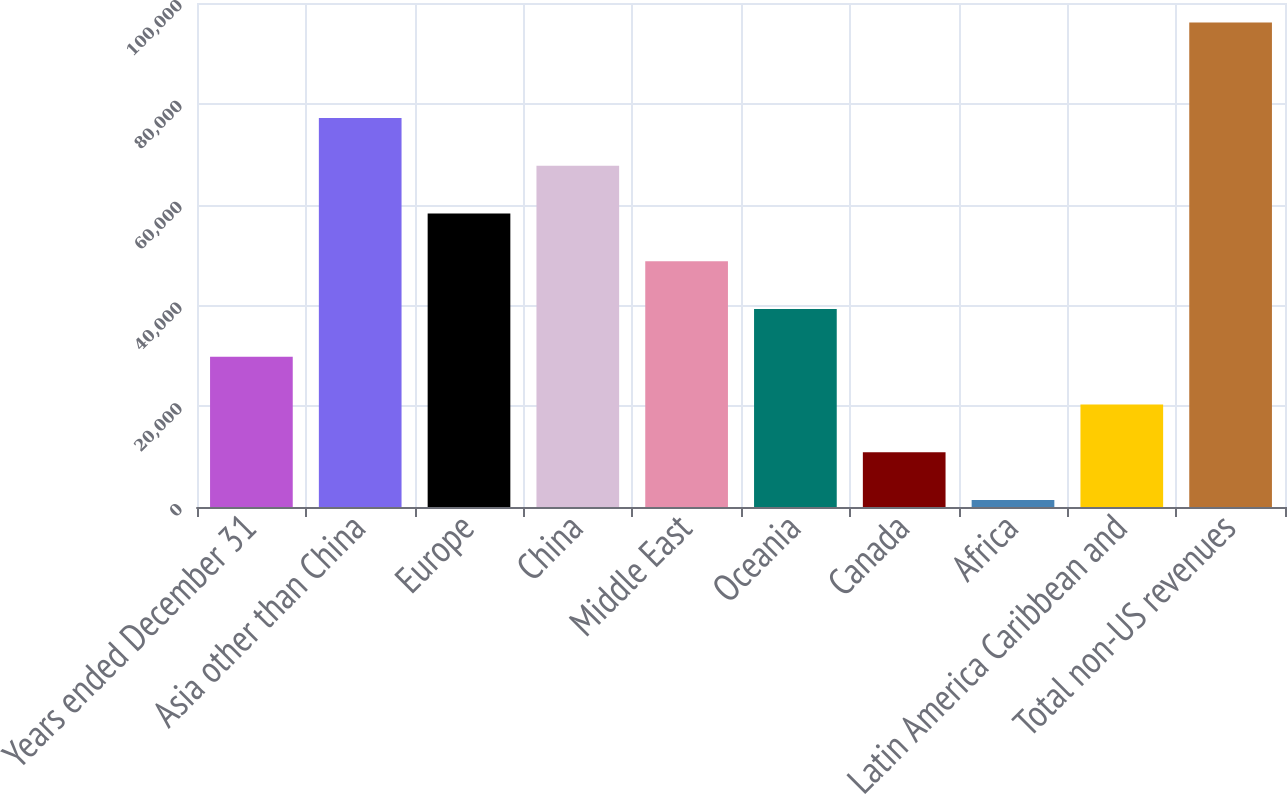<chart> <loc_0><loc_0><loc_500><loc_500><bar_chart><fcel>Years ended December 31<fcel>Asia other than China<fcel>Europe<fcel>China<fcel>Middle East<fcel>Oceania<fcel>Canada<fcel>Africa<fcel>Latin America Caribbean and<fcel>Total non-US revenues<nl><fcel>29812.8<fcel>77170.8<fcel>58227.6<fcel>67699.2<fcel>48756<fcel>39284.4<fcel>10869.6<fcel>1398<fcel>20341.2<fcel>96114<nl></chart> 